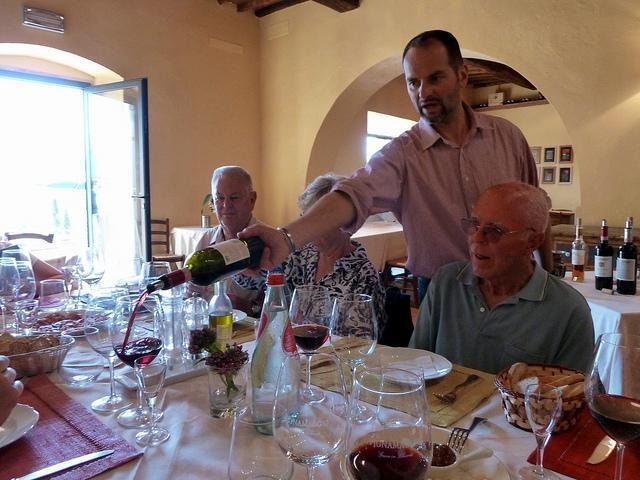From which fruit does the beverage served here come?
Make your selection from the four choices given to correctly answer the question.
Options: Banana, melon, grape, kiwi. Grape. 